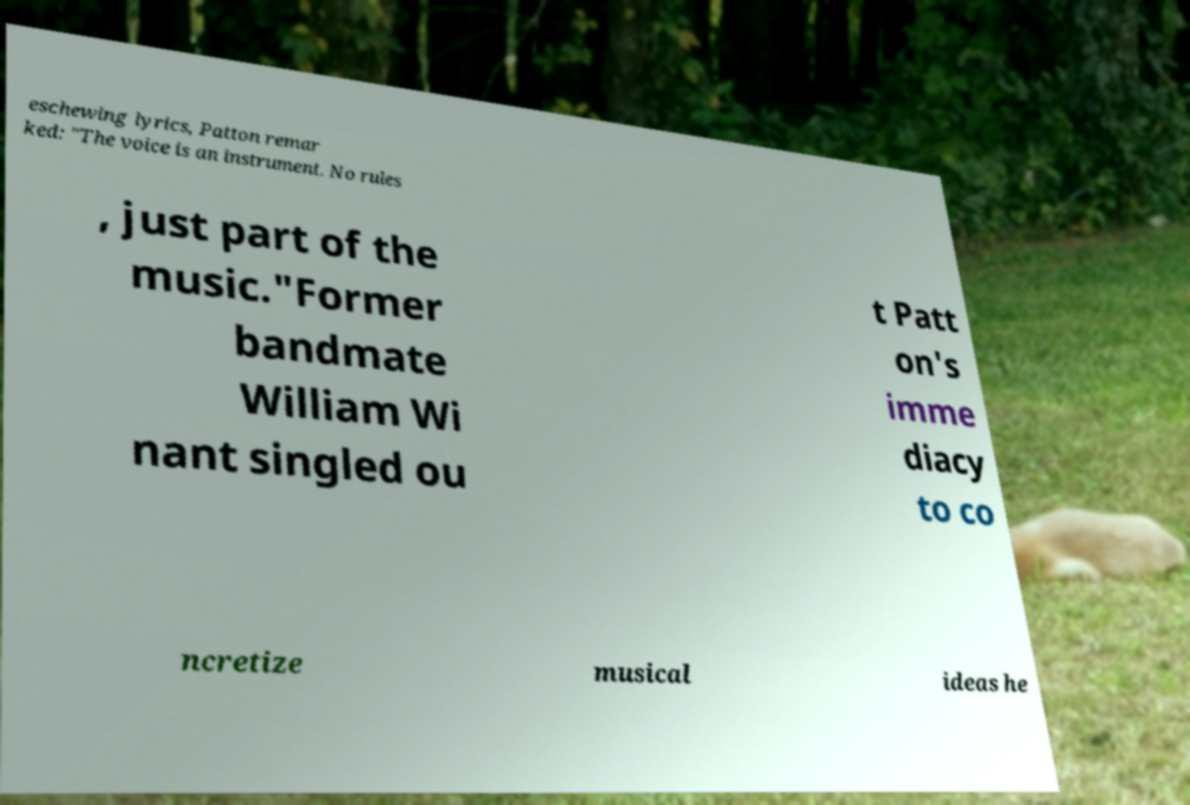Could you extract and type out the text from this image? eschewing lyrics, Patton remar ked: "The voice is an instrument. No rules , just part of the music."Former bandmate William Wi nant singled ou t Patt on's imme diacy to co ncretize musical ideas he 